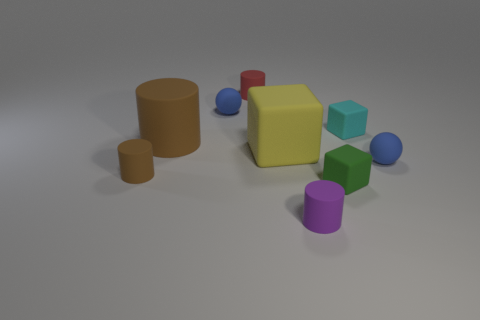Are there any red cylinders that have the same size as the purple rubber cylinder?
Give a very brief answer. Yes. What number of things are small rubber spheres to the right of the small red matte cylinder or blue objects that are on the right side of the small green object?
Your response must be concise. 1. There is a blue sphere right of the red rubber cylinder; is its size the same as the brown cylinder that is on the left side of the big brown object?
Give a very brief answer. Yes. There is a big thing that is on the right side of the big brown matte cylinder; is there a brown thing in front of it?
Provide a short and direct response. Yes. What number of rubber balls are behind the big yellow thing?
Keep it short and to the point. 1. How many other things are the same color as the large rubber cylinder?
Provide a succinct answer. 1. Is the number of tiny blue balls that are right of the red thing less than the number of small brown rubber things on the right side of the yellow rubber block?
Give a very brief answer. No. What number of things are either blue matte spheres in front of the tiny cyan object or small cubes?
Make the answer very short. 3. Do the purple thing and the green thing that is to the right of the purple object have the same size?
Your answer should be compact. Yes. What is the size of the cyan rubber object that is the same shape as the yellow rubber thing?
Ensure brevity in your answer.  Small. 